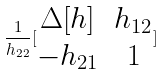<formula> <loc_0><loc_0><loc_500><loc_500>\frac { 1 } { h _ { 2 2 } } [ \begin{matrix} \Delta [ h ] & h _ { 1 2 } \\ - h _ { 2 1 } & 1 \end{matrix} ]</formula> 